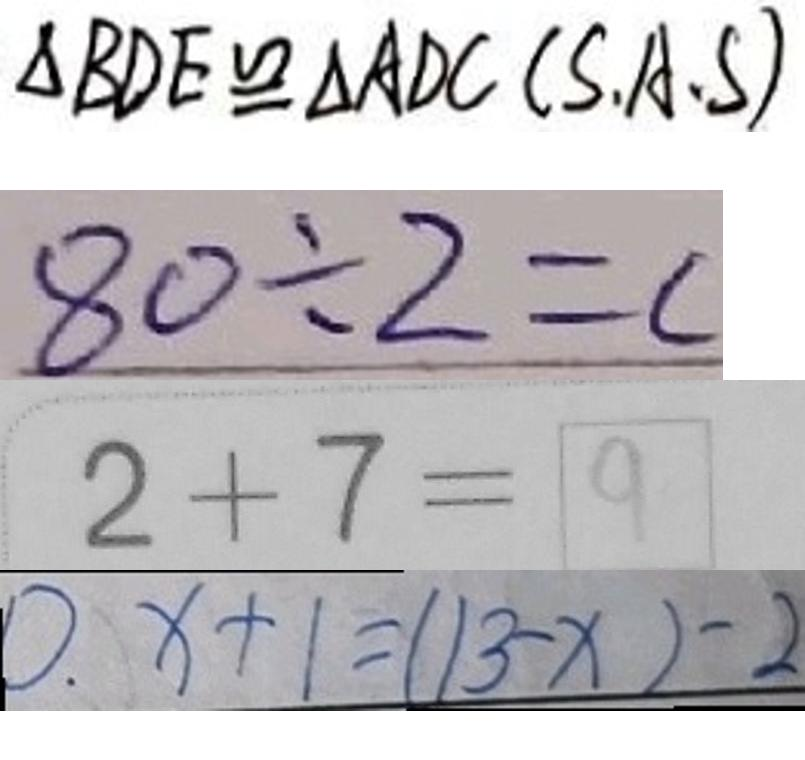Convert formula to latex. <formula><loc_0><loc_0><loc_500><loc_500>\Delta B D E \cong \Delta A D C ( S \cdot A \cdot S ) 
 8 0 \div 2 = c 
 2 + 7 = 9 
 0 . x + 1 = ( 1 3 - x ) - 2</formula> 